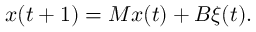<formula> <loc_0><loc_0><loc_500><loc_500>x ( t + 1 ) = M x ( t ) + B \xi ( t ) .</formula> 